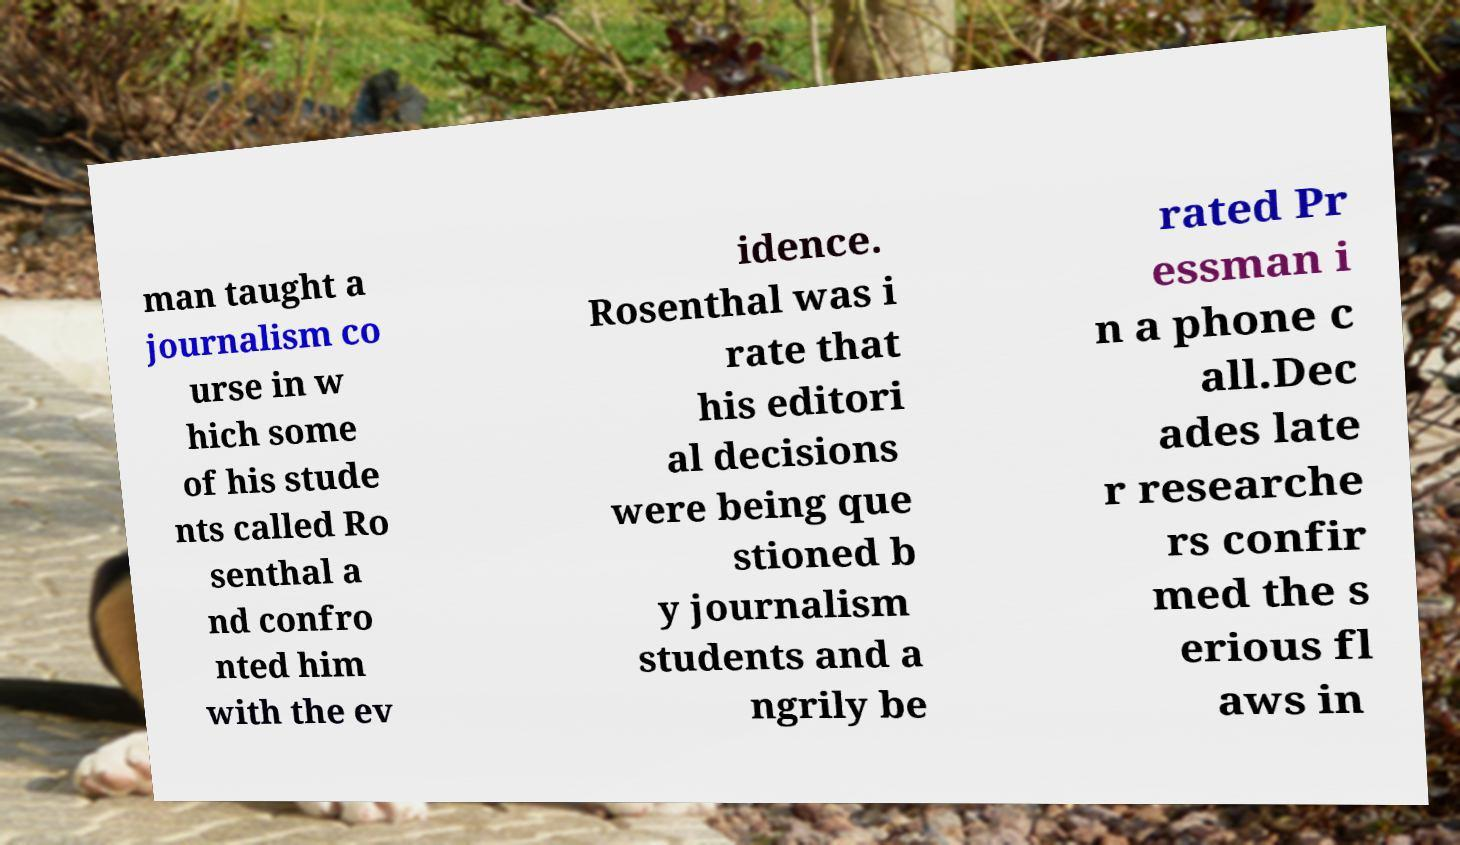Could you assist in decoding the text presented in this image and type it out clearly? man taught a journalism co urse in w hich some of his stude nts called Ro senthal a nd confro nted him with the ev idence. Rosenthal was i rate that his editori al decisions were being que stioned b y journalism students and a ngrily be rated Pr essman i n a phone c all.Dec ades late r researche rs confir med the s erious fl aws in 